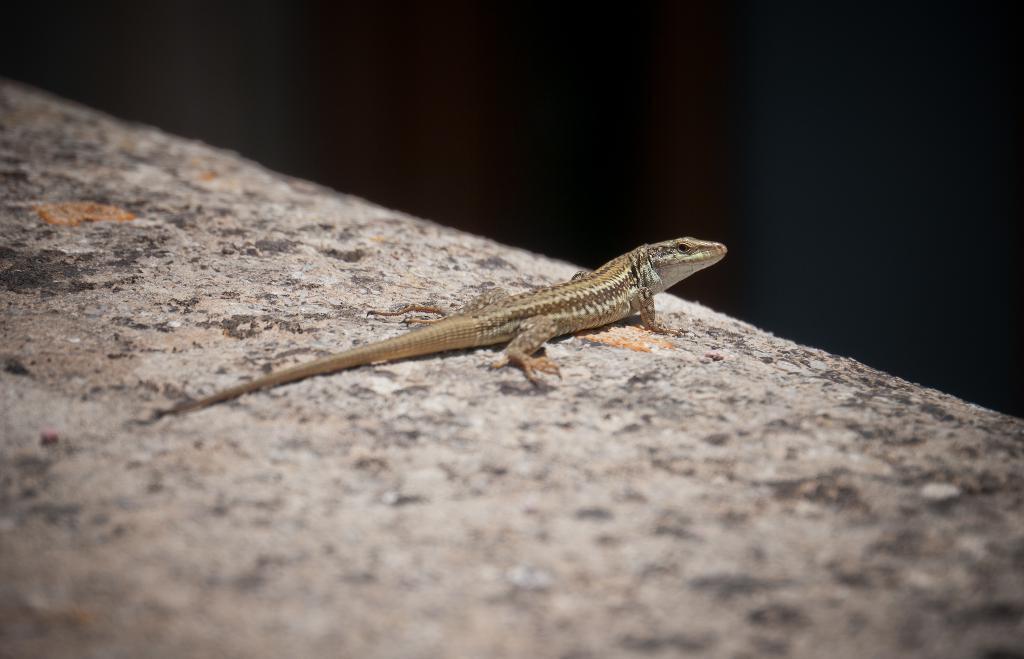How would you summarize this image in a sentence or two? In this image there is a brown color lizard which is lying on a stone. 